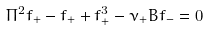Convert formula to latex. <formula><loc_0><loc_0><loc_500><loc_500>\Pi ^ { 2 } f _ { + } - f _ { + } + f _ { + } ^ { 3 } - \nu _ { + } B f _ { - } = 0</formula> 